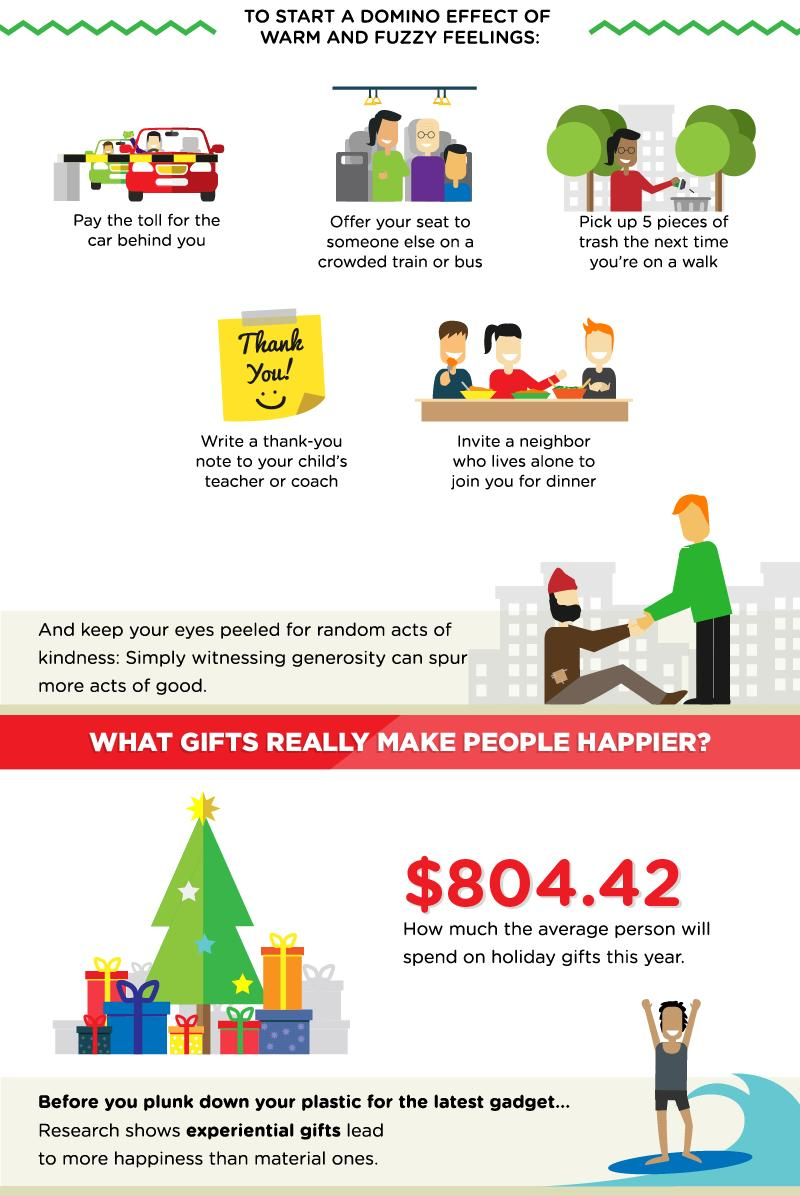Point out several critical features in this image. The fourth way to start a domino effect of warm and fuzzy feelings is by writing a thank-you note to your child's teacher or coach. 